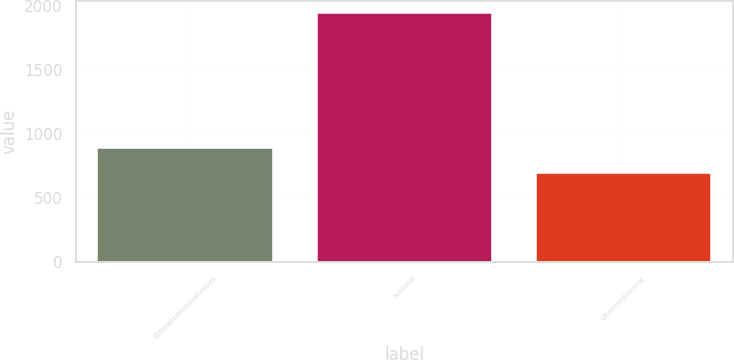<chart> <loc_0><loc_0><loc_500><loc_500><bar_chart><fcel>Estimatedresidualvalues<fcel>Subtotal<fcel>Unearnedincome<nl><fcel>887<fcel>1942<fcel>694<nl></chart> 